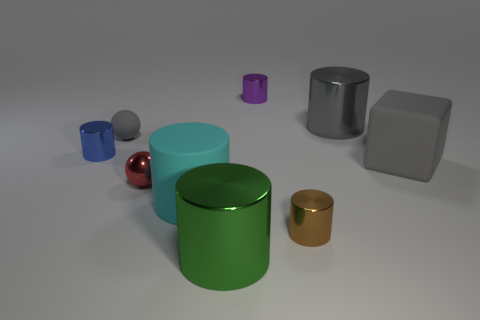Can you describe the largest object and its positioning in relation to the others? The largest object is the green metal cylinder located near the center of the image. It's placed vertically and holds a central position among the assorted objects. Its size and central placement give it visual prominence in the scene, and it appears to be balanced by the similarly shaped but smaller objects around it. 